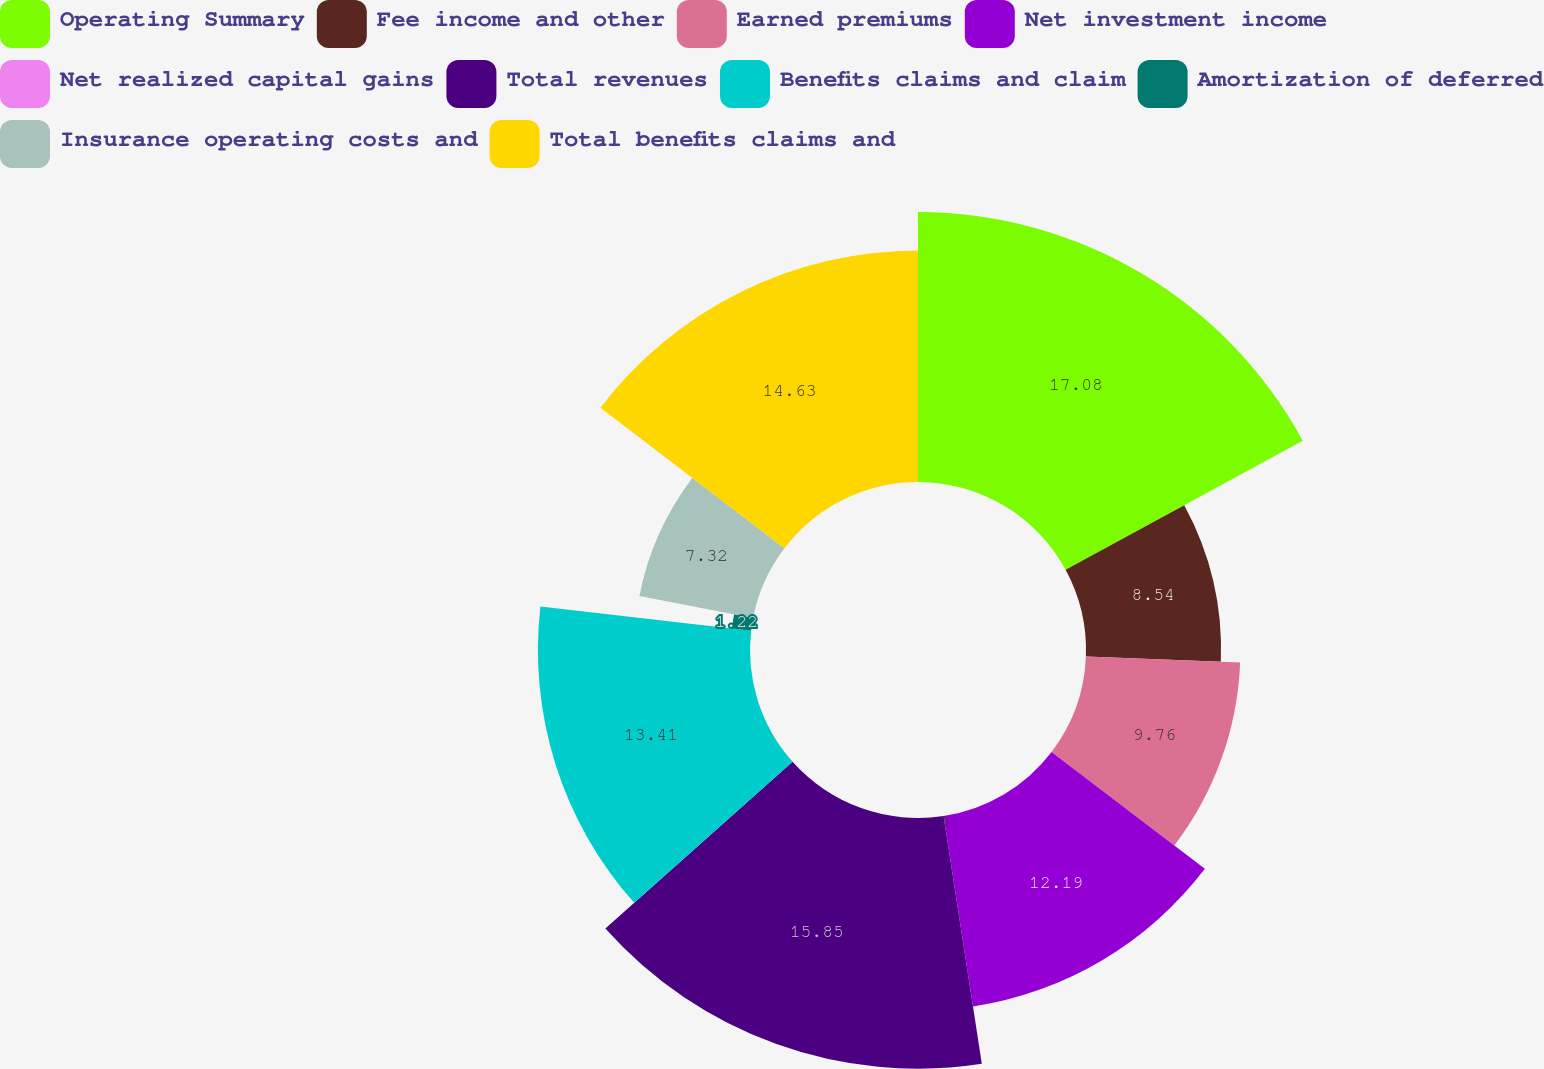Convert chart. <chart><loc_0><loc_0><loc_500><loc_500><pie_chart><fcel>Operating Summary<fcel>Fee income and other<fcel>Earned premiums<fcel>Net investment income<fcel>Net realized capital gains<fcel>Total revenues<fcel>Benefits claims and claim<fcel>Amortization of deferred<fcel>Insurance operating costs and<fcel>Total benefits claims and<nl><fcel>17.07%<fcel>8.54%<fcel>9.76%<fcel>12.19%<fcel>0.0%<fcel>15.85%<fcel>13.41%<fcel>1.22%<fcel>7.32%<fcel>14.63%<nl></chart> 